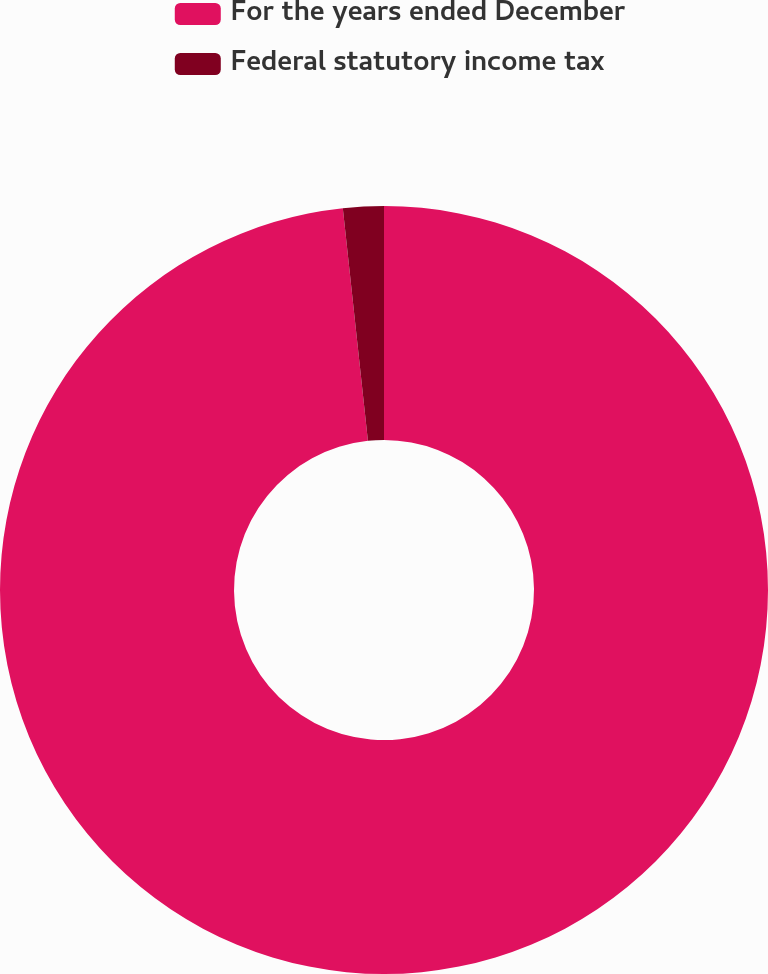Convert chart to OTSL. <chart><loc_0><loc_0><loc_500><loc_500><pie_chart><fcel>For the years ended December<fcel>Federal statutory income tax<nl><fcel>98.29%<fcel>1.71%<nl></chart> 